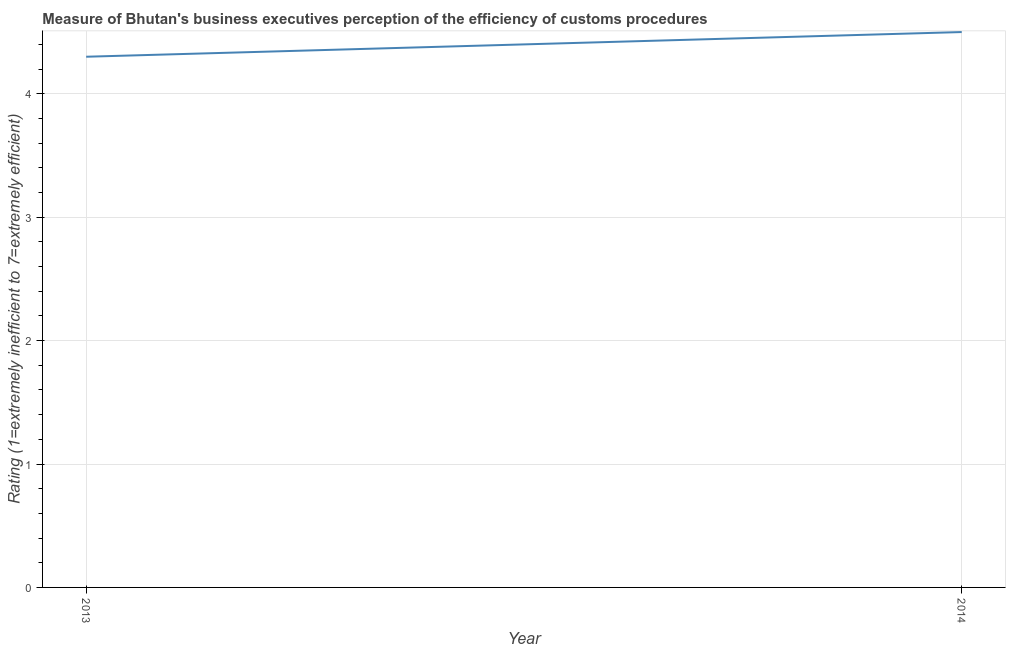What is the rating measuring burden of customs procedure in 2013?
Offer a very short reply. 4.3. Across all years, what is the minimum rating measuring burden of customs procedure?
Your answer should be compact. 4.3. In which year was the rating measuring burden of customs procedure maximum?
Your answer should be compact. 2014. What is the difference between the rating measuring burden of customs procedure in 2013 and 2014?
Offer a very short reply. -0.2. Do a majority of the years between 2013 and 2014 (inclusive) have rating measuring burden of customs procedure greater than 3.6 ?
Your answer should be very brief. Yes. What is the ratio of the rating measuring burden of customs procedure in 2013 to that in 2014?
Your answer should be very brief. 0.96. Does the rating measuring burden of customs procedure monotonically increase over the years?
Give a very brief answer. Yes. How many years are there in the graph?
Offer a terse response. 2. Are the values on the major ticks of Y-axis written in scientific E-notation?
Offer a terse response. No. What is the title of the graph?
Keep it short and to the point. Measure of Bhutan's business executives perception of the efficiency of customs procedures. What is the label or title of the Y-axis?
Provide a short and direct response. Rating (1=extremely inefficient to 7=extremely efficient). What is the difference between the Rating (1=extremely inefficient to 7=extremely efficient) in 2013 and 2014?
Offer a very short reply. -0.2. What is the ratio of the Rating (1=extremely inefficient to 7=extremely efficient) in 2013 to that in 2014?
Your answer should be compact. 0.96. 